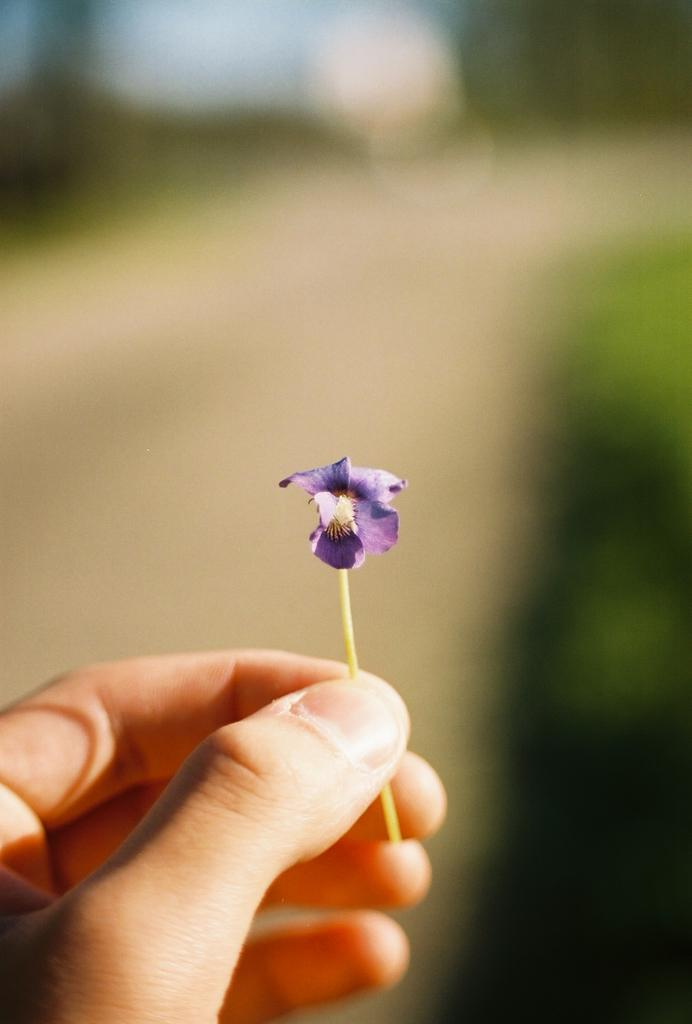What is the person holding in the image? There is a hand holding a small flower in the image. What color is the background of the flower? The background of the flower is blue. What grade did the family member receive on their recent exam? There is no information about a family member or an exam in the image, so it is not possible to answer that question. 